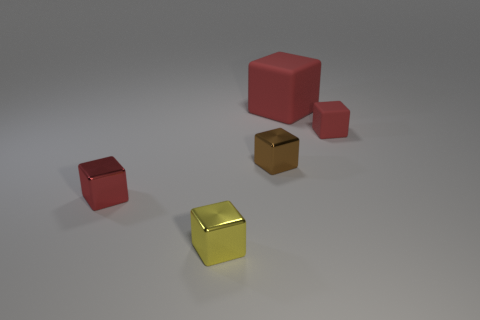How big is the metallic block behind the red thing in front of the metallic object that is right of the tiny yellow metal cube? The size of the metallic block in question is not clearly discernible from this perspective alone, but it appears to be moderately larger than the tiny yellow metal cube. To provide a precise measurement, we would need additional context or the ability to view the objects from multiple angles for accurate spatial comparison. 